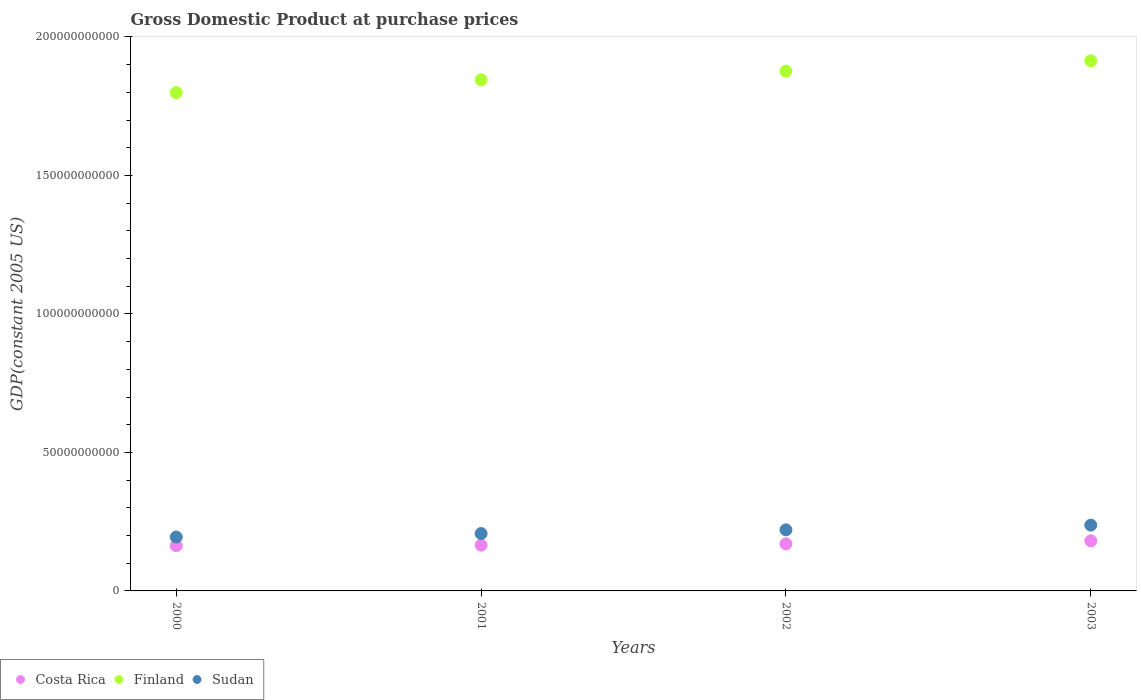How many different coloured dotlines are there?
Your answer should be very brief. 3. What is the GDP at purchase prices in Finland in 2003?
Offer a very short reply. 1.91e+11. Across all years, what is the maximum GDP at purchase prices in Sudan?
Offer a very short reply. 2.38e+1. Across all years, what is the minimum GDP at purchase prices in Finland?
Offer a very short reply. 1.80e+11. What is the total GDP at purchase prices in Costa Rica in the graph?
Offer a terse response. 6.79e+1. What is the difference between the GDP at purchase prices in Costa Rica in 2001 and that in 2003?
Offer a terse response. -1.57e+09. What is the difference between the GDP at purchase prices in Costa Rica in 2003 and the GDP at purchase prices in Sudan in 2001?
Give a very brief answer. -2.63e+09. What is the average GDP at purchase prices in Sudan per year?
Keep it short and to the point. 2.15e+1. In the year 2001, what is the difference between the GDP at purchase prices in Costa Rica and GDP at purchase prices in Finland?
Provide a short and direct response. -1.68e+11. In how many years, is the GDP at purchase prices in Sudan greater than 100000000000 US$?
Your response must be concise. 0. What is the ratio of the GDP at purchase prices in Finland in 2001 to that in 2003?
Your response must be concise. 0.96. Is the difference between the GDP at purchase prices in Costa Rica in 2000 and 2001 greater than the difference between the GDP at purchase prices in Finland in 2000 and 2001?
Offer a very short reply. Yes. What is the difference between the highest and the second highest GDP at purchase prices in Costa Rica?
Make the answer very short. 1.09e+09. What is the difference between the highest and the lowest GDP at purchase prices in Costa Rica?
Give a very brief answer. 1.74e+09. Is the sum of the GDP at purchase prices in Finland in 2001 and 2003 greater than the maximum GDP at purchase prices in Sudan across all years?
Keep it short and to the point. Yes. Does the GDP at purchase prices in Finland monotonically increase over the years?
Offer a very short reply. Yes. Is the GDP at purchase prices in Costa Rica strictly greater than the GDP at purchase prices in Finland over the years?
Provide a succinct answer. No. Is the GDP at purchase prices in Sudan strictly less than the GDP at purchase prices in Costa Rica over the years?
Your answer should be compact. No. Are the values on the major ticks of Y-axis written in scientific E-notation?
Offer a very short reply. No. Does the graph contain grids?
Give a very brief answer. No. How many legend labels are there?
Give a very brief answer. 3. How are the legend labels stacked?
Offer a very short reply. Horizontal. What is the title of the graph?
Provide a succinct answer. Gross Domestic Product at purchase prices. Does "Ecuador" appear as one of the legend labels in the graph?
Give a very brief answer. No. What is the label or title of the X-axis?
Ensure brevity in your answer.  Years. What is the label or title of the Y-axis?
Provide a short and direct response. GDP(constant 2005 US). What is the GDP(constant 2005 US) of Costa Rica in 2000?
Make the answer very short. 1.63e+1. What is the GDP(constant 2005 US) of Finland in 2000?
Keep it short and to the point. 1.80e+11. What is the GDP(constant 2005 US) of Sudan in 2000?
Make the answer very short. 1.95e+1. What is the GDP(constant 2005 US) of Costa Rica in 2001?
Your response must be concise. 1.65e+1. What is the GDP(constant 2005 US) in Finland in 2001?
Give a very brief answer. 1.85e+11. What is the GDP(constant 2005 US) of Sudan in 2001?
Offer a very short reply. 2.07e+1. What is the GDP(constant 2005 US) of Costa Rica in 2002?
Your answer should be very brief. 1.70e+1. What is the GDP(constant 2005 US) of Finland in 2002?
Your answer should be very brief. 1.88e+11. What is the GDP(constant 2005 US) of Sudan in 2002?
Ensure brevity in your answer.  2.20e+1. What is the GDP(constant 2005 US) in Costa Rica in 2003?
Make the answer very short. 1.81e+1. What is the GDP(constant 2005 US) in Finland in 2003?
Provide a short and direct response. 1.91e+11. What is the GDP(constant 2005 US) in Sudan in 2003?
Your response must be concise. 2.38e+1. Across all years, what is the maximum GDP(constant 2005 US) in Costa Rica?
Offer a very short reply. 1.81e+1. Across all years, what is the maximum GDP(constant 2005 US) of Finland?
Make the answer very short. 1.91e+11. Across all years, what is the maximum GDP(constant 2005 US) in Sudan?
Provide a succinct answer. 2.38e+1. Across all years, what is the minimum GDP(constant 2005 US) in Costa Rica?
Make the answer very short. 1.63e+1. Across all years, what is the minimum GDP(constant 2005 US) of Finland?
Your answer should be very brief. 1.80e+11. Across all years, what is the minimum GDP(constant 2005 US) in Sudan?
Give a very brief answer. 1.95e+1. What is the total GDP(constant 2005 US) of Costa Rica in the graph?
Your response must be concise. 6.79e+1. What is the total GDP(constant 2005 US) of Finland in the graph?
Offer a very short reply. 7.43e+11. What is the total GDP(constant 2005 US) in Sudan in the graph?
Your answer should be compact. 8.60e+1. What is the difference between the GDP(constant 2005 US) of Costa Rica in 2000 and that in 2001?
Ensure brevity in your answer.  -1.76e+08. What is the difference between the GDP(constant 2005 US) of Finland in 2000 and that in 2001?
Ensure brevity in your answer.  -4.64e+09. What is the difference between the GDP(constant 2005 US) in Sudan in 2000 and that in 2001?
Your answer should be compact. -1.26e+09. What is the difference between the GDP(constant 2005 US) in Costa Rica in 2000 and that in 2002?
Make the answer very short. -6.55e+08. What is the difference between the GDP(constant 2005 US) in Finland in 2000 and that in 2002?
Provide a short and direct response. -7.74e+09. What is the difference between the GDP(constant 2005 US) of Sudan in 2000 and that in 2002?
Your answer should be compact. -2.60e+09. What is the difference between the GDP(constant 2005 US) in Costa Rica in 2000 and that in 2003?
Ensure brevity in your answer.  -1.74e+09. What is the difference between the GDP(constant 2005 US) in Finland in 2000 and that in 2003?
Provide a succinct answer. -1.15e+1. What is the difference between the GDP(constant 2005 US) of Sudan in 2000 and that in 2003?
Your answer should be compact. -4.30e+09. What is the difference between the GDP(constant 2005 US) of Costa Rica in 2001 and that in 2002?
Keep it short and to the point. -4.79e+08. What is the difference between the GDP(constant 2005 US) in Finland in 2001 and that in 2002?
Keep it short and to the point. -3.10e+09. What is the difference between the GDP(constant 2005 US) in Sudan in 2001 and that in 2002?
Provide a succinct answer. -1.33e+09. What is the difference between the GDP(constant 2005 US) of Costa Rica in 2001 and that in 2003?
Your answer should be very brief. -1.57e+09. What is the difference between the GDP(constant 2005 US) of Finland in 2001 and that in 2003?
Keep it short and to the point. -6.84e+09. What is the difference between the GDP(constant 2005 US) of Sudan in 2001 and that in 2003?
Make the answer very short. -3.04e+09. What is the difference between the GDP(constant 2005 US) of Costa Rica in 2002 and that in 2003?
Offer a very short reply. -1.09e+09. What is the difference between the GDP(constant 2005 US) in Finland in 2002 and that in 2003?
Ensure brevity in your answer.  -3.74e+09. What is the difference between the GDP(constant 2005 US) of Sudan in 2002 and that in 2003?
Make the answer very short. -1.71e+09. What is the difference between the GDP(constant 2005 US) in Costa Rica in 2000 and the GDP(constant 2005 US) in Finland in 2001?
Provide a short and direct response. -1.68e+11. What is the difference between the GDP(constant 2005 US) of Costa Rica in 2000 and the GDP(constant 2005 US) of Sudan in 2001?
Your answer should be very brief. -4.38e+09. What is the difference between the GDP(constant 2005 US) in Finland in 2000 and the GDP(constant 2005 US) in Sudan in 2001?
Your answer should be compact. 1.59e+11. What is the difference between the GDP(constant 2005 US) of Costa Rica in 2000 and the GDP(constant 2005 US) of Finland in 2002?
Provide a succinct answer. -1.71e+11. What is the difference between the GDP(constant 2005 US) in Costa Rica in 2000 and the GDP(constant 2005 US) in Sudan in 2002?
Make the answer very short. -5.71e+09. What is the difference between the GDP(constant 2005 US) of Finland in 2000 and the GDP(constant 2005 US) of Sudan in 2002?
Ensure brevity in your answer.  1.58e+11. What is the difference between the GDP(constant 2005 US) in Costa Rica in 2000 and the GDP(constant 2005 US) in Finland in 2003?
Keep it short and to the point. -1.75e+11. What is the difference between the GDP(constant 2005 US) in Costa Rica in 2000 and the GDP(constant 2005 US) in Sudan in 2003?
Provide a succinct answer. -7.41e+09. What is the difference between the GDP(constant 2005 US) of Finland in 2000 and the GDP(constant 2005 US) of Sudan in 2003?
Your answer should be very brief. 1.56e+11. What is the difference between the GDP(constant 2005 US) of Costa Rica in 2001 and the GDP(constant 2005 US) of Finland in 2002?
Keep it short and to the point. -1.71e+11. What is the difference between the GDP(constant 2005 US) of Costa Rica in 2001 and the GDP(constant 2005 US) of Sudan in 2002?
Your answer should be very brief. -5.53e+09. What is the difference between the GDP(constant 2005 US) of Finland in 2001 and the GDP(constant 2005 US) of Sudan in 2002?
Your response must be concise. 1.63e+11. What is the difference between the GDP(constant 2005 US) in Costa Rica in 2001 and the GDP(constant 2005 US) in Finland in 2003?
Ensure brevity in your answer.  -1.75e+11. What is the difference between the GDP(constant 2005 US) in Costa Rica in 2001 and the GDP(constant 2005 US) in Sudan in 2003?
Give a very brief answer. -7.24e+09. What is the difference between the GDP(constant 2005 US) of Finland in 2001 and the GDP(constant 2005 US) of Sudan in 2003?
Make the answer very short. 1.61e+11. What is the difference between the GDP(constant 2005 US) of Costa Rica in 2002 and the GDP(constant 2005 US) of Finland in 2003?
Your response must be concise. -1.74e+11. What is the difference between the GDP(constant 2005 US) of Costa Rica in 2002 and the GDP(constant 2005 US) of Sudan in 2003?
Your answer should be very brief. -6.76e+09. What is the difference between the GDP(constant 2005 US) in Finland in 2002 and the GDP(constant 2005 US) in Sudan in 2003?
Keep it short and to the point. 1.64e+11. What is the average GDP(constant 2005 US) of Costa Rica per year?
Keep it short and to the point. 1.70e+1. What is the average GDP(constant 2005 US) of Finland per year?
Give a very brief answer. 1.86e+11. What is the average GDP(constant 2005 US) in Sudan per year?
Give a very brief answer. 2.15e+1. In the year 2000, what is the difference between the GDP(constant 2005 US) in Costa Rica and GDP(constant 2005 US) in Finland?
Provide a short and direct response. -1.64e+11. In the year 2000, what is the difference between the GDP(constant 2005 US) in Costa Rica and GDP(constant 2005 US) in Sudan?
Your answer should be compact. -3.11e+09. In the year 2000, what is the difference between the GDP(constant 2005 US) of Finland and GDP(constant 2005 US) of Sudan?
Provide a succinct answer. 1.60e+11. In the year 2001, what is the difference between the GDP(constant 2005 US) of Costa Rica and GDP(constant 2005 US) of Finland?
Keep it short and to the point. -1.68e+11. In the year 2001, what is the difference between the GDP(constant 2005 US) of Costa Rica and GDP(constant 2005 US) of Sudan?
Provide a short and direct response. -4.20e+09. In the year 2001, what is the difference between the GDP(constant 2005 US) in Finland and GDP(constant 2005 US) in Sudan?
Provide a succinct answer. 1.64e+11. In the year 2002, what is the difference between the GDP(constant 2005 US) of Costa Rica and GDP(constant 2005 US) of Finland?
Your answer should be very brief. -1.71e+11. In the year 2002, what is the difference between the GDP(constant 2005 US) of Costa Rica and GDP(constant 2005 US) of Sudan?
Provide a succinct answer. -5.05e+09. In the year 2002, what is the difference between the GDP(constant 2005 US) in Finland and GDP(constant 2005 US) in Sudan?
Provide a succinct answer. 1.66e+11. In the year 2003, what is the difference between the GDP(constant 2005 US) in Costa Rica and GDP(constant 2005 US) in Finland?
Provide a succinct answer. -1.73e+11. In the year 2003, what is the difference between the GDP(constant 2005 US) in Costa Rica and GDP(constant 2005 US) in Sudan?
Make the answer very short. -5.67e+09. In the year 2003, what is the difference between the GDP(constant 2005 US) of Finland and GDP(constant 2005 US) of Sudan?
Ensure brevity in your answer.  1.68e+11. What is the ratio of the GDP(constant 2005 US) of Costa Rica in 2000 to that in 2001?
Ensure brevity in your answer.  0.99. What is the ratio of the GDP(constant 2005 US) of Finland in 2000 to that in 2001?
Make the answer very short. 0.97. What is the ratio of the GDP(constant 2005 US) in Sudan in 2000 to that in 2001?
Keep it short and to the point. 0.94. What is the ratio of the GDP(constant 2005 US) of Costa Rica in 2000 to that in 2002?
Your answer should be compact. 0.96. What is the ratio of the GDP(constant 2005 US) of Finland in 2000 to that in 2002?
Ensure brevity in your answer.  0.96. What is the ratio of the GDP(constant 2005 US) in Sudan in 2000 to that in 2002?
Provide a short and direct response. 0.88. What is the ratio of the GDP(constant 2005 US) of Costa Rica in 2000 to that in 2003?
Give a very brief answer. 0.9. What is the ratio of the GDP(constant 2005 US) of Finland in 2000 to that in 2003?
Provide a succinct answer. 0.94. What is the ratio of the GDP(constant 2005 US) of Sudan in 2000 to that in 2003?
Keep it short and to the point. 0.82. What is the ratio of the GDP(constant 2005 US) of Costa Rica in 2001 to that in 2002?
Provide a succinct answer. 0.97. What is the ratio of the GDP(constant 2005 US) of Finland in 2001 to that in 2002?
Offer a very short reply. 0.98. What is the ratio of the GDP(constant 2005 US) of Sudan in 2001 to that in 2002?
Offer a very short reply. 0.94. What is the ratio of the GDP(constant 2005 US) of Costa Rica in 2001 to that in 2003?
Make the answer very short. 0.91. What is the ratio of the GDP(constant 2005 US) in Finland in 2001 to that in 2003?
Make the answer very short. 0.96. What is the ratio of the GDP(constant 2005 US) of Sudan in 2001 to that in 2003?
Offer a very short reply. 0.87. What is the ratio of the GDP(constant 2005 US) in Costa Rica in 2002 to that in 2003?
Provide a short and direct response. 0.94. What is the ratio of the GDP(constant 2005 US) in Finland in 2002 to that in 2003?
Keep it short and to the point. 0.98. What is the ratio of the GDP(constant 2005 US) of Sudan in 2002 to that in 2003?
Provide a succinct answer. 0.93. What is the difference between the highest and the second highest GDP(constant 2005 US) of Costa Rica?
Keep it short and to the point. 1.09e+09. What is the difference between the highest and the second highest GDP(constant 2005 US) of Finland?
Your answer should be very brief. 3.74e+09. What is the difference between the highest and the second highest GDP(constant 2005 US) in Sudan?
Make the answer very short. 1.71e+09. What is the difference between the highest and the lowest GDP(constant 2005 US) of Costa Rica?
Offer a terse response. 1.74e+09. What is the difference between the highest and the lowest GDP(constant 2005 US) of Finland?
Make the answer very short. 1.15e+1. What is the difference between the highest and the lowest GDP(constant 2005 US) of Sudan?
Ensure brevity in your answer.  4.30e+09. 